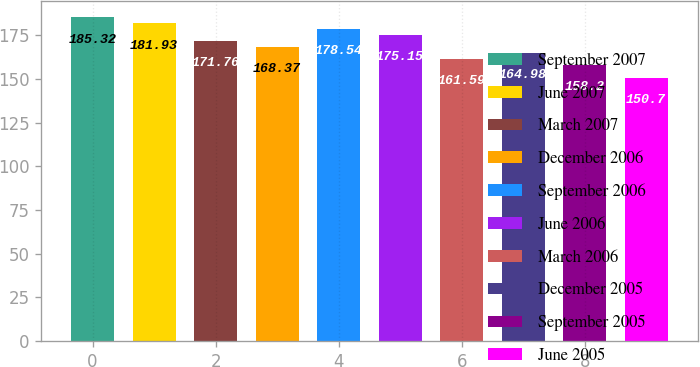Convert chart to OTSL. <chart><loc_0><loc_0><loc_500><loc_500><bar_chart><fcel>September 2007<fcel>June 2007<fcel>March 2007<fcel>December 2006<fcel>September 2006<fcel>June 2006<fcel>March 2006<fcel>December 2005<fcel>September 2005<fcel>June 2005<nl><fcel>185.32<fcel>181.93<fcel>171.76<fcel>168.37<fcel>178.54<fcel>175.15<fcel>161.59<fcel>164.98<fcel>158.2<fcel>150.7<nl></chart> 